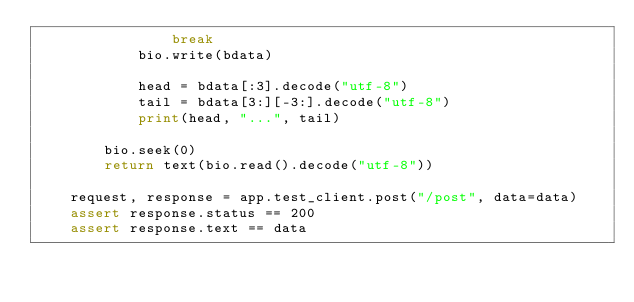<code> <loc_0><loc_0><loc_500><loc_500><_Python_>                break
            bio.write(bdata)

            head = bdata[:3].decode("utf-8")
            tail = bdata[3:][-3:].decode("utf-8")
            print(head, "...", tail)

        bio.seek(0)
        return text(bio.read().decode("utf-8"))

    request, response = app.test_client.post("/post", data=data)
    assert response.status == 200
    assert response.text == data
</code> 